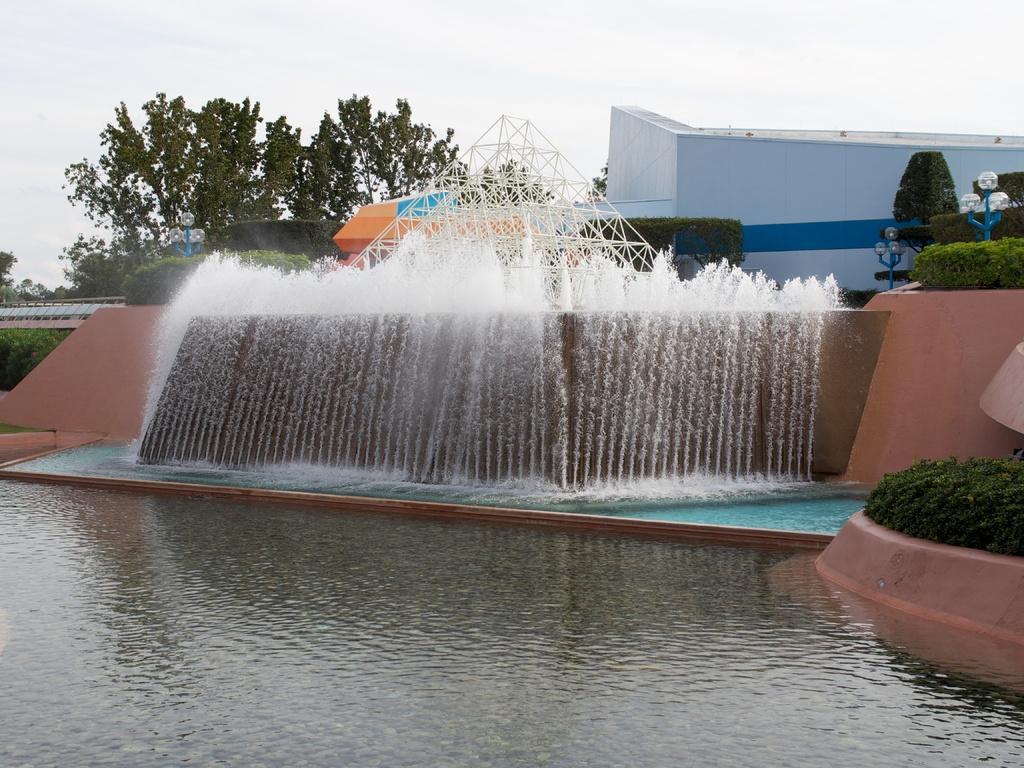Can you describe this image briefly? In this image there is a swimming pool, near to the swimming pool there is a fountain, in the background there are trees, shed and a sky. 